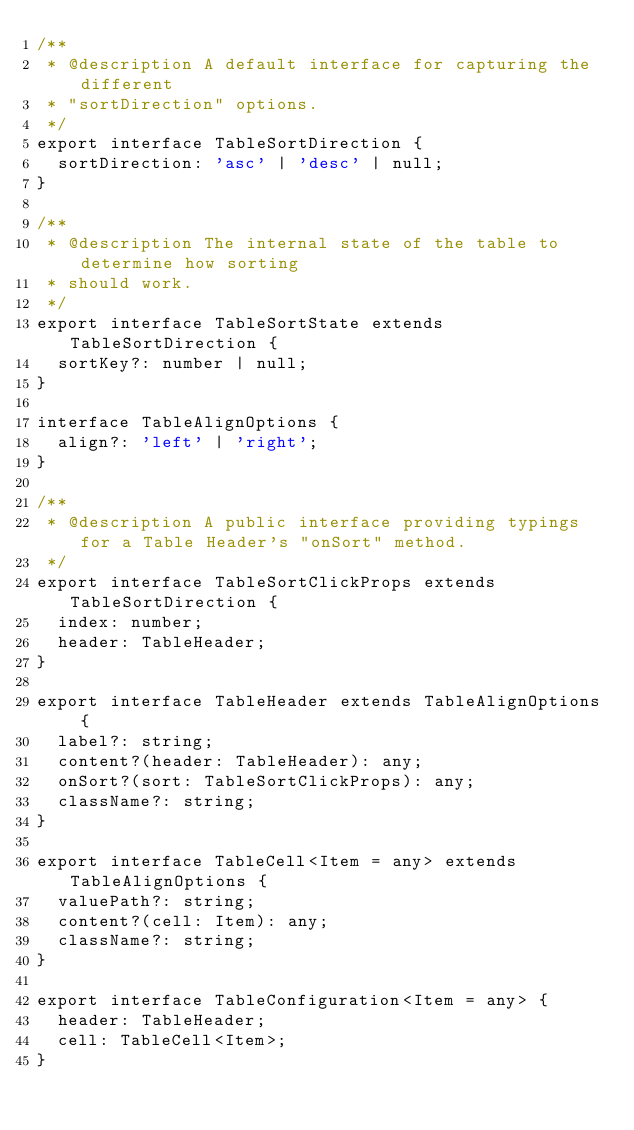<code> <loc_0><loc_0><loc_500><loc_500><_TypeScript_>/**
 * @description A default interface for capturing the different
 * "sortDirection" options.
 */
export interface TableSortDirection {
  sortDirection: 'asc' | 'desc' | null;
}

/**
 * @description The internal state of the table to determine how sorting
 * should work.
 */
export interface TableSortState extends TableSortDirection {
  sortKey?: number | null;
}

interface TableAlignOptions {
  align?: 'left' | 'right';
}

/**
 * @description A public interface providing typings for a Table Header's "onSort" method.
 */
export interface TableSortClickProps extends TableSortDirection {
  index: number;
  header: TableHeader;
}

export interface TableHeader extends TableAlignOptions {
  label?: string;
  content?(header: TableHeader): any;
  onSort?(sort: TableSortClickProps): any;
  className?: string;
}

export interface TableCell<Item = any> extends TableAlignOptions {
  valuePath?: string;
  content?(cell: Item): any;
  className?: string;
}

export interface TableConfiguration<Item = any> {
  header: TableHeader;
  cell: TableCell<Item>;
}
</code> 